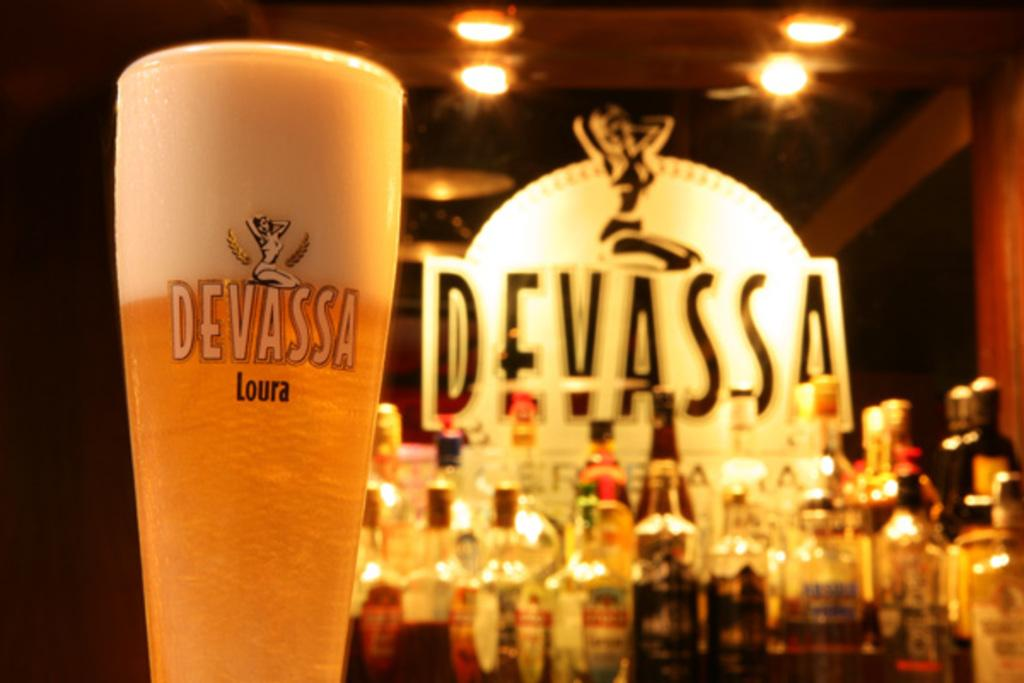What type of drink is in the glass on the left side of the image? There is a glass of beer in the image. What other alcoholic beverages can be seen in the image? There are wine bottles in the background of the image. Can you describe the roof in the image? The image shows a roof with a lightning arrangement. What type of owl can be seen perched on the roof in the image? There is no owl present in the image; it only shows a roof with a lightning arrangement. 